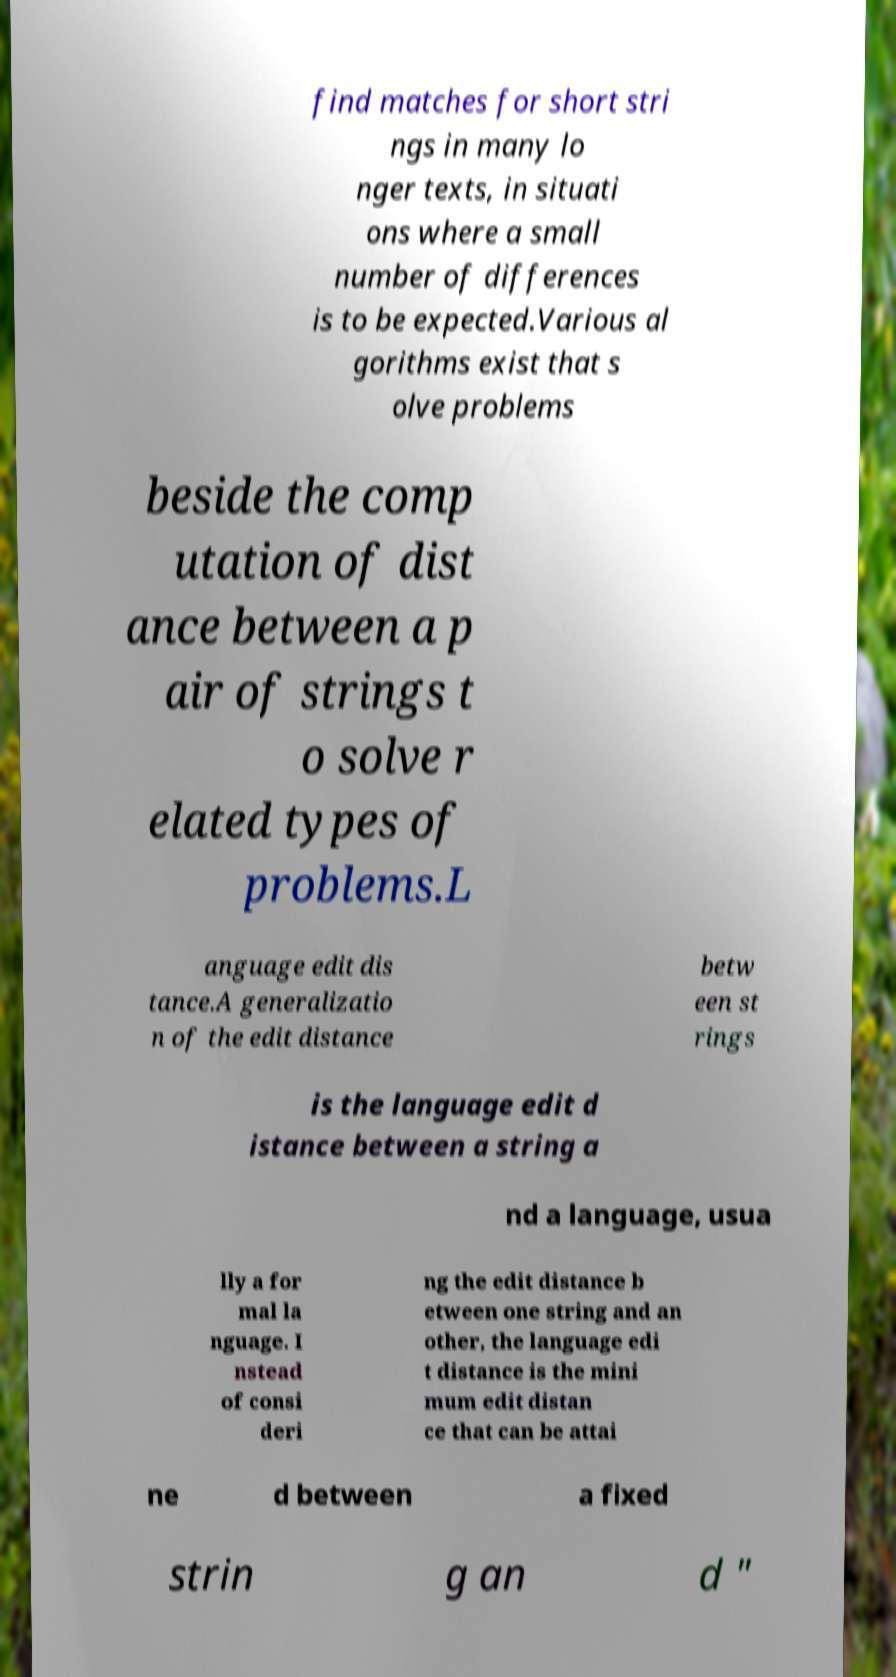For documentation purposes, I need the text within this image transcribed. Could you provide that? find matches for short stri ngs in many lo nger texts, in situati ons where a small number of differences is to be expected.Various al gorithms exist that s olve problems beside the comp utation of dist ance between a p air of strings t o solve r elated types of problems.L anguage edit dis tance.A generalizatio n of the edit distance betw een st rings is the language edit d istance between a string a nd a language, usua lly a for mal la nguage. I nstead of consi deri ng the edit distance b etween one string and an other, the language edi t distance is the mini mum edit distan ce that can be attai ne d between a fixed strin g an d " 